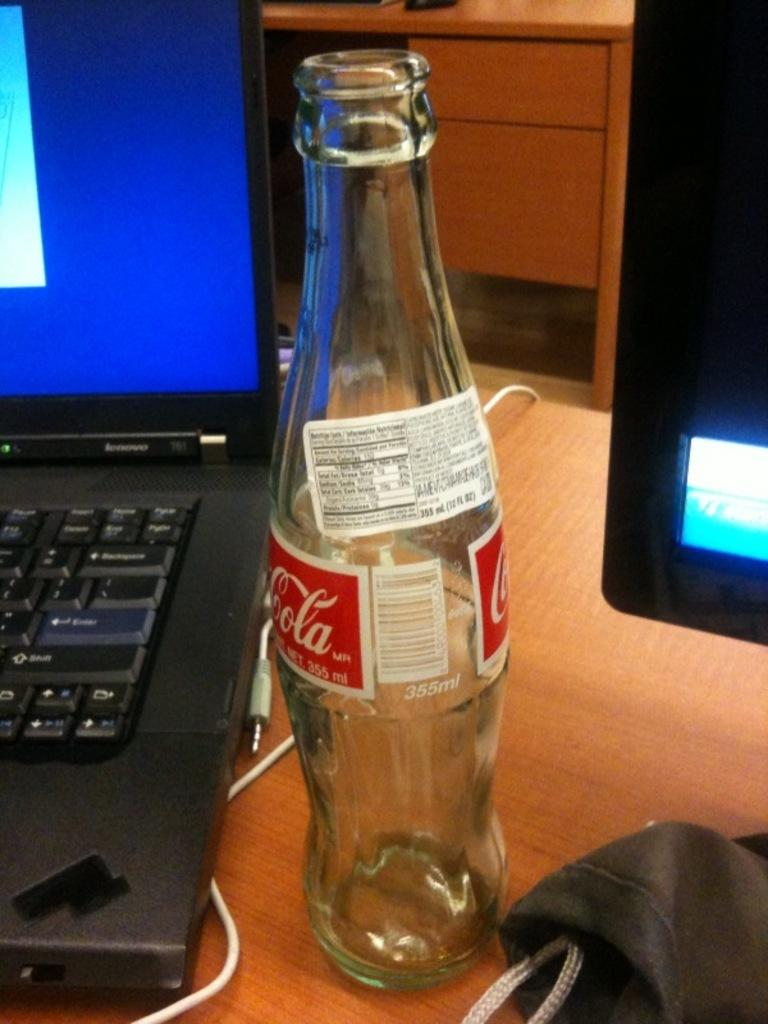<image>
Summarize the visual content of the image. A Cola bottle sitting in between a laptop computer and computer monitor 